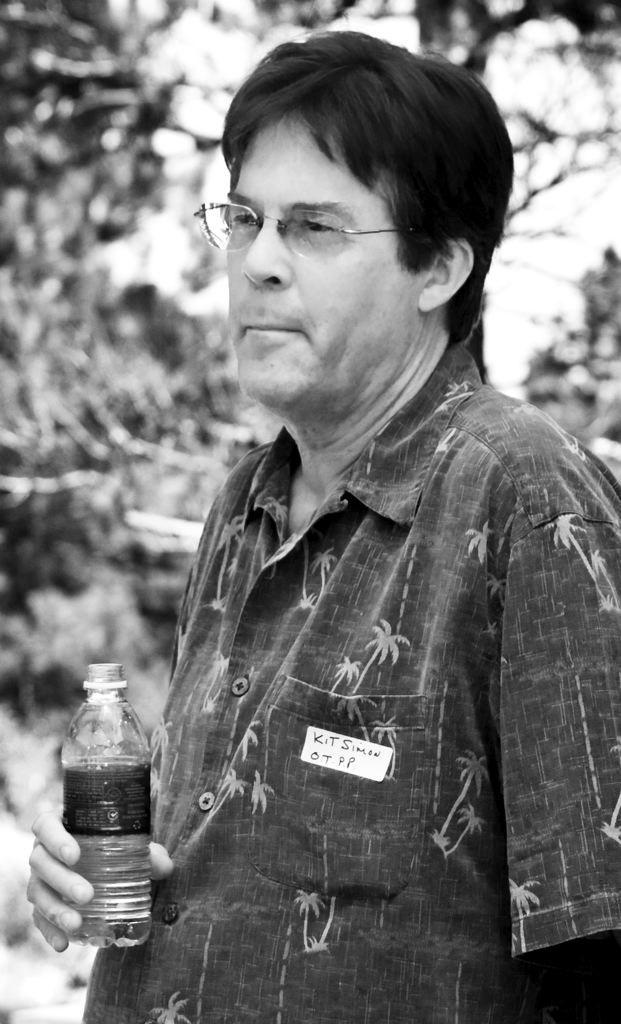Who is present in the image? There is a man in the image. What is the man wearing? The man is wearing a shirt and spectacles. What is the man holding in the image? The man is holding a water bottle. What can be seen in the background of the image? There is a tree in the background of the image. What type of soup is the man eating in the image? There is no soup present in the image; the man is holding a water bottle. Can you see a flame in the image? There is no flame present in the image. 